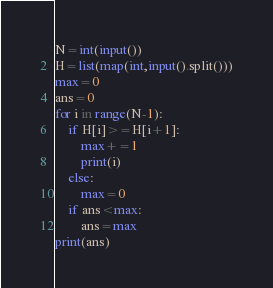<code> <loc_0><loc_0><loc_500><loc_500><_Python_>N=int(input())
H=list(map(int,input().split()))
max=0
ans=0
for i in range(N-1):
    if H[i]>=H[i+1]:
        max+=1
        print(i)
    else:
        max=0
    if ans<max:
        ans=max
print(ans)</code> 